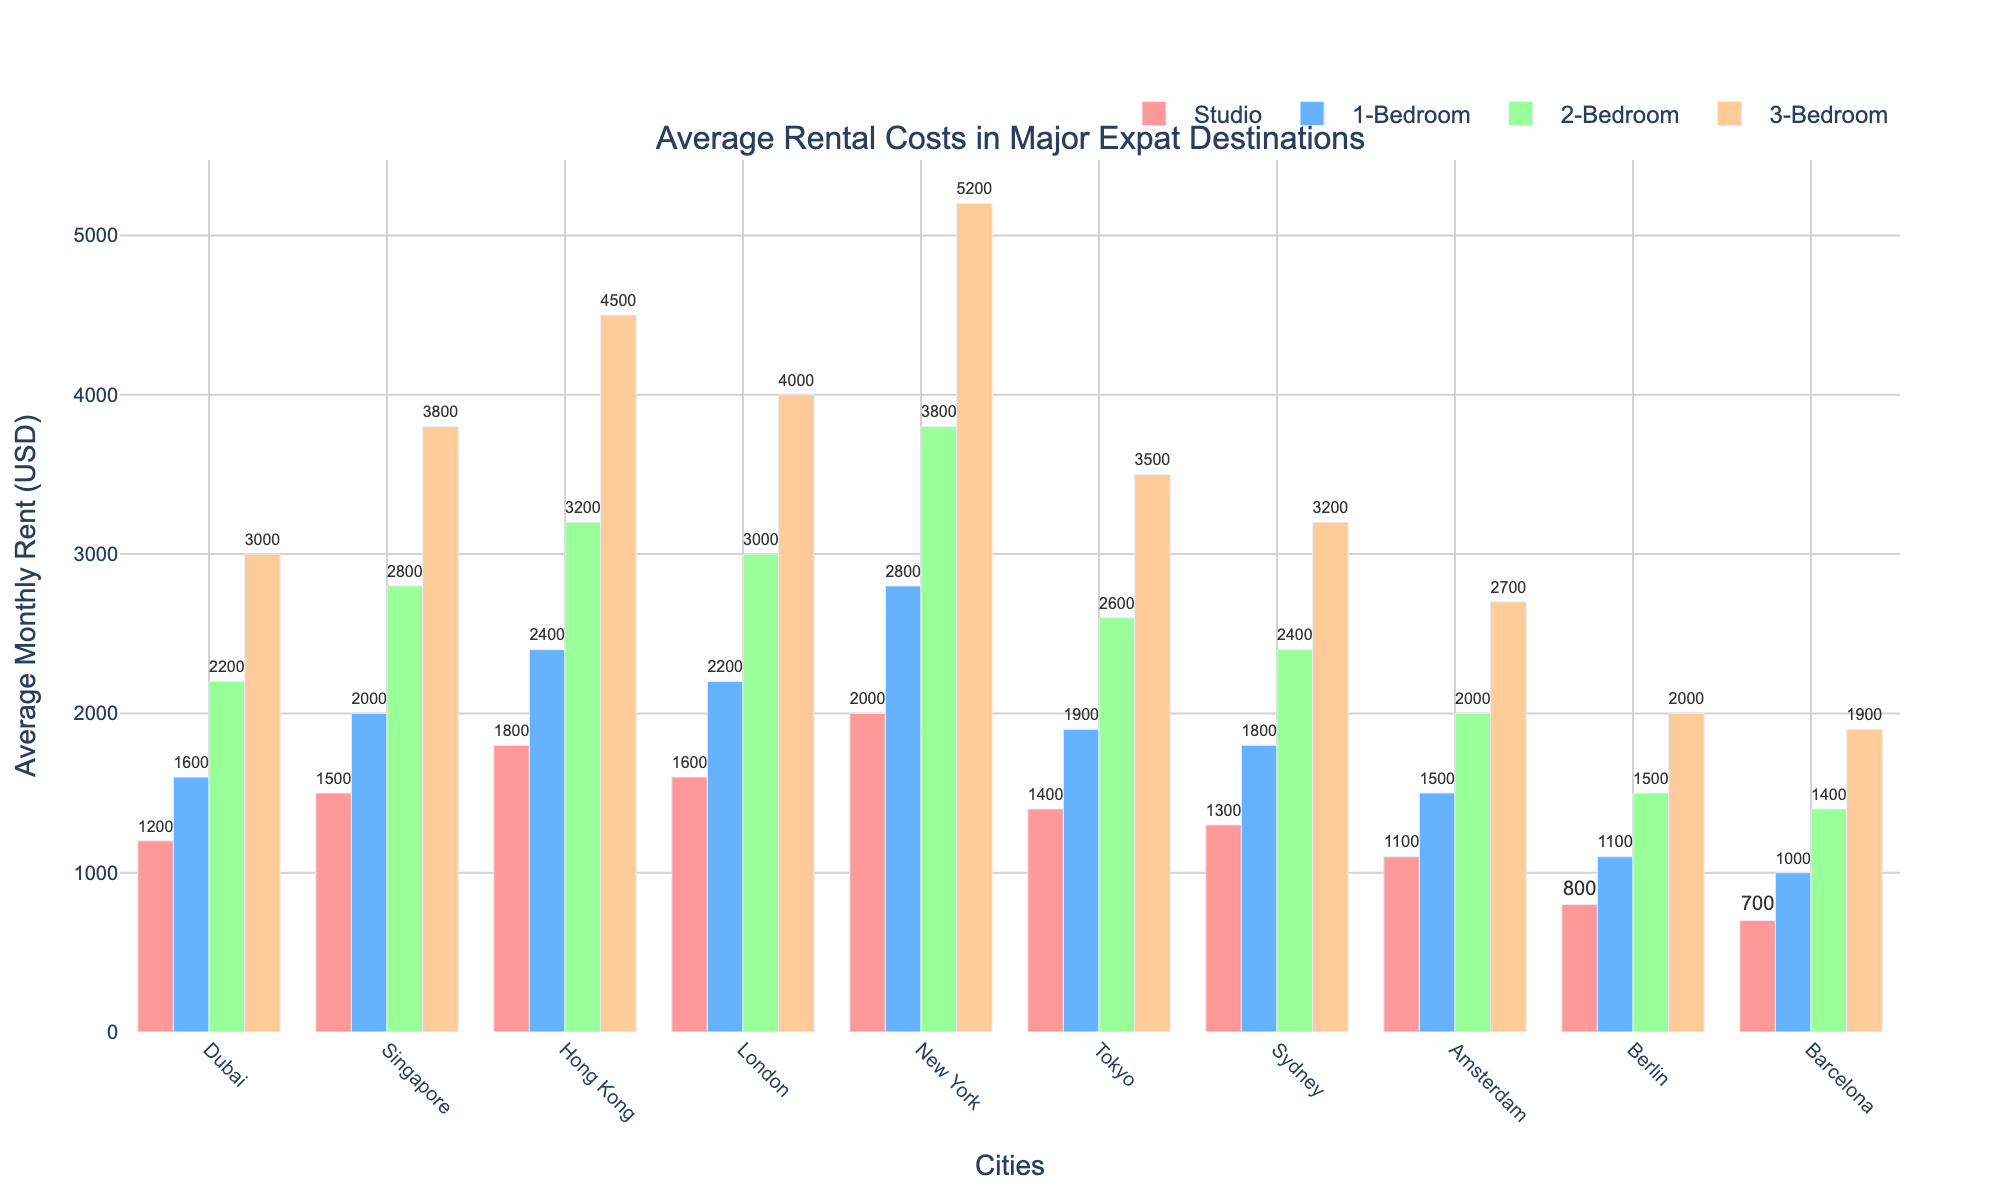What city has the highest average rental cost for a studio apartment? By observing the heights of the bars for Studio apartments, identify the highest one. The highest bar for Studio apartments is in New York.
Answer: New York Which city has the lowest average rental cost for a 3-bedroom apartment? By looking at the bars for 3-Bedroom apartments, find the shortest bar. The shortest 3-Bedroom bar corresponds to Barcelona with average rental costs of 1900 USD.
Answer: Barcelona How much more expensive is the average rent for a 1-bedroom apartment in New York compared to Berlin? Locate the bars for 1-Bedroom apartments for both New York and Berlin. Subtract Berlin's value from New York's value (2800 - 1100).
Answer: 1700 USD What's the sum of the average rental costs for a 2-bedroom apartment across Singapore and Dubai? Identify and add the average rents for 2-Bedroom apartments in Singapore and Dubai (2800 in Singapore + 2200 in Dubai).
Answer: 5000 USD Which city has a closer average rent for a 3-Bedroom apartment to 3000 USD, Dubai or Tokyo? Check the average rents for 3-Bedroom apartments in Dubai and Tokyo. Dubai's value is 3000 USD and Tokyo's is 3500 USD. 3000 USD is closer to 3000 USD.
Answer: Dubai In which city are the average rental costs for a Studio apartment and a 2-Bedroom apartment equal or closest? Compare the difference between the bars for Studio and 2-Bedroom apartments in all cities. The smallest difference can be seen for Berlin (800 for Studio and 1500 for 2-Bedroom).
Answer: Berlin Which city has a greater difference in rent between a Studio and a 1-Bedroom apartment, Amsterdam or Sydney? Subtract the Studio rent from the 1-Bedroom rent for both cities (1500 - 1100 for Amsterdam, 1800 - 1300 for Sydney). Compare the differences (400 for Amsterdam and 500 for Sydney).
Answer: Sydney What is the average rental price for a 1-Bedroom apartment across all cities? Sum the rental prices for 1-Bedroom apartments for all cities and divide by the number of cities ((1600 + 2000 + 2400 + 2200 + 2800 + 1900 + 1800 + 1500 + 1100 + 1000) / 10).
Answer: 2030 USD Which city shows the most significant increase in average rental cost when moving from a 1-Bedroom to a 2-Bedroom apartment? For each city, calculate the difference between 1-Bedroom and 2-Bedroom rents. The largest difference can be seen in New York (3800 - 2800).
Answer: New York How much would the total rent be for a 3-Bedroom apartment in London and a Studio in Hong Kong? Sum the average rental costs for a 3-Bedroom apartment in London and a Studio in Hong Kong (4000 for London + 1800 for Hong Kong).
Answer: 5800 USD 